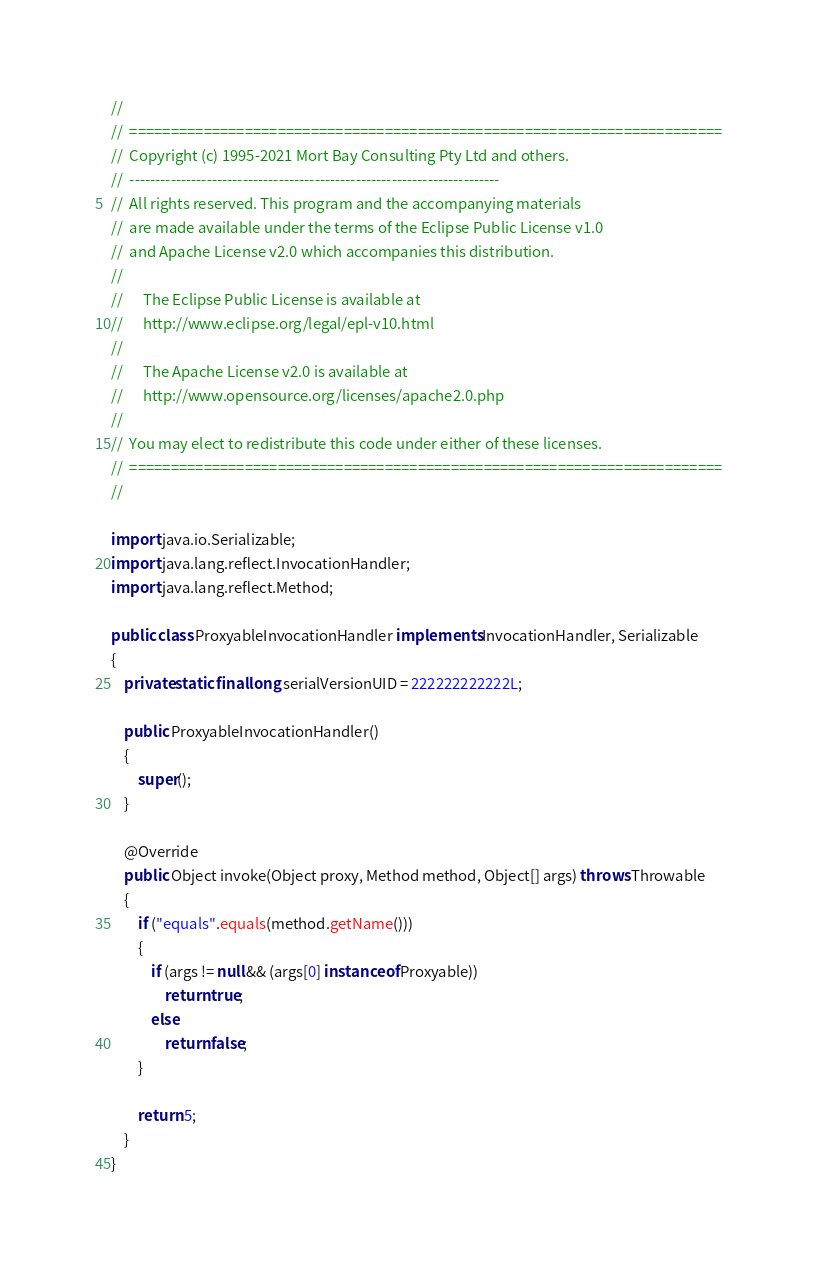Convert code to text. <code><loc_0><loc_0><loc_500><loc_500><_Java_>//
//  ========================================================================
//  Copyright (c) 1995-2021 Mort Bay Consulting Pty Ltd and others.
//  ------------------------------------------------------------------------
//  All rights reserved. This program and the accompanying materials
//  are made available under the terms of the Eclipse Public License v1.0
//  and Apache License v2.0 which accompanies this distribution.
//
//      The Eclipse Public License is available at
//      http://www.eclipse.org/legal/epl-v10.html
//
//      The Apache License v2.0 is available at
//      http://www.opensource.org/licenses/apache2.0.php
//
//  You may elect to redistribute this code under either of these licenses.
//  ========================================================================
//

import java.io.Serializable;
import java.lang.reflect.InvocationHandler;
import java.lang.reflect.Method;

public class ProxyableInvocationHandler implements InvocationHandler, Serializable
{
    private static final long serialVersionUID = 222222222222L;

    public ProxyableInvocationHandler()
    {
        super();
    }

    @Override
    public Object invoke(Object proxy, Method method, Object[] args) throws Throwable
    {
        if ("equals".equals(method.getName()))
        {
            if (args != null && (args[0] instanceof Proxyable))
                return true;
            else
                return false;
        }

        return 5;
    }
}
</code> 